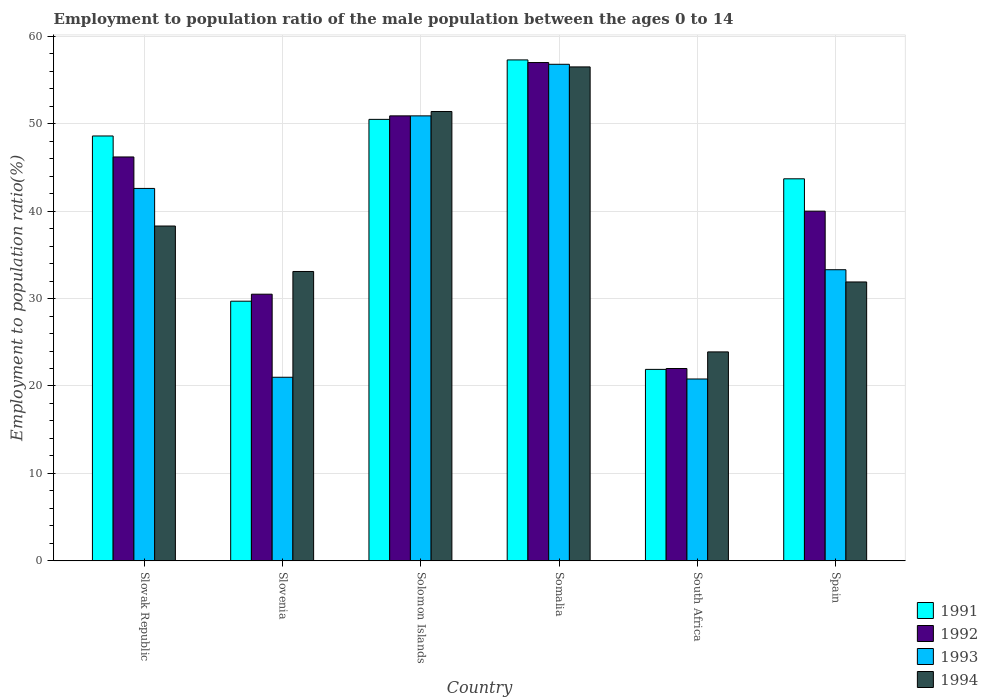How many different coloured bars are there?
Offer a very short reply. 4. Are the number of bars per tick equal to the number of legend labels?
Your response must be concise. Yes. What is the label of the 4th group of bars from the left?
Provide a short and direct response. Somalia. What is the employment to population ratio in 1994 in Somalia?
Offer a very short reply. 56.5. Across all countries, what is the minimum employment to population ratio in 1991?
Your answer should be compact. 21.9. In which country was the employment to population ratio in 1992 maximum?
Your answer should be very brief. Somalia. In which country was the employment to population ratio in 1992 minimum?
Provide a short and direct response. South Africa. What is the total employment to population ratio in 1993 in the graph?
Make the answer very short. 225.4. What is the difference between the employment to population ratio in 1993 in Slovenia and that in South Africa?
Keep it short and to the point. 0.2. What is the difference between the employment to population ratio in 1993 in Somalia and the employment to population ratio in 1992 in Slovenia?
Offer a terse response. 26.3. What is the average employment to population ratio in 1992 per country?
Your answer should be very brief. 41.1. What is the difference between the employment to population ratio of/in 1994 and employment to population ratio of/in 1991 in Solomon Islands?
Ensure brevity in your answer.  0.9. In how many countries, is the employment to population ratio in 1991 greater than 24 %?
Offer a very short reply. 5. What is the ratio of the employment to population ratio in 1991 in Slovak Republic to that in Slovenia?
Offer a very short reply. 1.64. What is the difference between the highest and the second highest employment to population ratio in 1992?
Offer a very short reply. 6.1. What is the difference between the highest and the lowest employment to population ratio in 1991?
Your response must be concise. 35.4. In how many countries, is the employment to population ratio in 1994 greater than the average employment to population ratio in 1994 taken over all countries?
Your response must be concise. 2. Is the sum of the employment to population ratio in 1991 in Somalia and Spain greater than the maximum employment to population ratio in 1992 across all countries?
Offer a terse response. Yes. Is it the case that in every country, the sum of the employment to population ratio in 1992 and employment to population ratio in 1994 is greater than the sum of employment to population ratio in 1993 and employment to population ratio in 1991?
Ensure brevity in your answer.  No. What does the 2nd bar from the left in Somalia represents?
Offer a terse response. 1992. Are all the bars in the graph horizontal?
Provide a succinct answer. No. Does the graph contain any zero values?
Offer a terse response. No. Does the graph contain grids?
Offer a terse response. Yes. How are the legend labels stacked?
Keep it short and to the point. Vertical. What is the title of the graph?
Offer a terse response. Employment to population ratio of the male population between the ages 0 to 14. Does "1963" appear as one of the legend labels in the graph?
Provide a succinct answer. No. What is the label or title of the X-axis?
Offer a very short reply. Country. What is the label or title of the Y-axis?
Give a very brief answer. Employment to population ratio(%). What is the Employment to population ratio(%) in 1991 in Slovak Republic?
Offer a very short reply. 48.6. What is the Employment to population ratio(%) in 1992 in Slovak Republic?
Keep it short and to the point. 46.2. What is the Employment to population ratio(%) in 1993 in Slovak Republic?
Give a very brief answer. 42.6. What is the Employment to population ratio(%) in 1994 in Slovak Republic?
Offer a very short reply. 38.3. What is the Employment to population ratio(%) of 1991 in Slovenia?
Give a very brief answer. 29.7. What is the Employment to population ratio(%) in 1992 in Slovenia?
Give a very brief answer. 30.5. What is the Employment to population ratio(%) in 1993 in Slovenia?
Offer a terse response. 21. What is the Employment to population ratio(%) of 1994 in Slovenia?
Provide a succinct answer. 33.1. What is the Employment to population ratio(%) in 1991 in Solomon Islands?
Provide a short and direct response. 50.5. What is the Employment to population ratio(%) in 1992 in Solomon Islands?
Your answer should be compact. 50.9. What is the Employment to population ratio(%) of 1993 in Solomon Islands?
Provide a short and direct response. 50.9. What is the Employment to population ratio(%) in 1994 in Solomon Islands?
Offer a very short reply. 51.4. What is the Employment to population ratio(%) in 1991 in Somalia?
Your answer should be very brief. 57.3. What is the Employment to population ratio(%) in 1993 in Somalia?
Ensure brevity in your answer.  56.8. What is the Employment to population ratio(%) of 1994 in Somalia?
Provide a succinct answer. 56.5. What is the Employment to population ratio(%) of 1991 in South Africa?
Offer a very short reply. 21.9. What is the Employment to population ratio(%) of 1992 in South Africa?
Provide a succinct answer. 22. What is the Employment to population ratio(%) of 1993 in South Africa?
Ensure brevity in your answer.  20.8. What is the Employment to population ratio(%) in 1994 in South Africa?
Give a very brief answer. 23.9. What is the Employment to population ratio(%) of 1991 in Spain?
Provide a short and direct response. 43.7. What is the Employment to population ratio(%) in 1992 in Spain?
Your response must be concise. 40. What is the Employment to population ratio(%) of 1993 in Spain?
Offer a terse response. 33.3. What is the Employment to population ratio(%) in 1994 in Spain?
Make the answer very short. 31.9. Across all countries, what is the maximum Employment to population ratio(%) in 1991?
Offer a very short reply. 57.3. Across all countries, what is the maximum Employment to population ratio(%) of 1992?
Keep it short and to the point. 57. Across all countries, what is the maximum Employment to population ratio(%) of 1993?
Give a very brief answer. 56.8. Across all countries, what is the maximum Employment to population ratio(%) of 1994?
Give a very brief answer. 56.5. Across all countries, what is the minimum Employment to population ratio(%) of 1991?
Make the answer very short. 21.9. Across all countries, what is the minimum Employment to population ratio(%) of 1993?
Keep it short and to the point. 20.8. Across all countries, what is the minimum Employment to population ratio(%) of 1994?
Provide a short and direct response. 23.9. What is the total Employment to population ratio(%) of 1991 in the graph?
Make the answer very short. 251.7. What is the total Employment to population ratio(%) in 1992 in the graph?
Provide a succinct answer. 246.6. What is the total Employment to population ratio(%) in 1993 in the graph?
Offer a very short reply. 225.4. What is the total Employment to population ratio(%) of 1994 in the graph?
Offer a very short reply. 235.1. What is the difference between the Employment to population ratio(%) of 1992 in Slovak Republic and that in Slovenia?
Give a very brief answer. 15.7. What is the difference between the Employment to population ratio(%) in 1993 in Slovak Republic and that in Slovenia?
Offer a very short reply. 21.6. What is the difference between the Employment to population ratio(%) of 1991 in Slovak Republic and that in Solomon Islands?
Offer a very short reply. -1.9. What is the difference between the Employment to population ratio(%) of 1993 in Slovak Republic and that in Solomon Islands?
Your answer should be compact. -8.3. What is the difference between the Employment to population ratio(%) in 1994 in Slovak Republic and that in Solomon Islands?
Your answer should be very brief. -13.1. What is the difference between the Employment to population ratio(%) of 1993 in Slovak Republic and that in Somalia?
Your answer should be compact. -14.2. What is the difference between the Employment to population ratio(%) of 1994 in Slovak Republic and that in Somalia?
Provide a short and direct response. -18.2. What is the difference between the Employment to population ratio(%) of 1991 in Slovak Republic and that in South Africa?
Offer a very short reply. 26.7. What is the difference between the Employment to population ratio(%) in 1992 in Slovak Republic and that in South Africa?
Your response must be concise. 24.2. What is the difference between the Employment to population ratio(%) in 1993 in Slovak Republic and that in South Africa?
Your response must be concise. 21.8. What is the difference between the Employment to population ratio(%) of 1991 in Slovak Republic and that in Spain?
Provide a short and direct response. 4.9. What is the difference between the Employment to population ratio(%) of 1992 in Slovak Republic and that in Spain?
Give a very brief answer. 6.2. What is the difference between the Employment to population ratio(%) of 1993 in Slovak Republic and that in Spain?
Make the answer very short. 9.3. What is the difference between the Employment to population ratio(%) of 1991 in Slovenia and that in Solomon Islands?
Make the answer very short. -20.8. What is the difference between the Employment to population ratio(%) in 1992 in Slovenia and that in Solomon Islands?
Give a very brief answer. -20.4. What is the difference between the Employment to population ratio(%) of 1993 in Slovenia and that in Solomon Islands?
Keep it short and to the point. -29.9. What is the difference between the Employment to population ratio(%) in 1994 in Slovenia and that in Solomon Islands?
Give a very brief answer. -18.3. What is the difference between the Employment to population ratio(%) of 1991 in Slovenia and that in Somalia?
Your answer should be very brief. -27.6. What is the difference between the Employment to population ratio(%) in 1992 in Slovenia and that in Somalia?
Give a very brief answer. -26.5. What is the difference between the Employment to population ratio(%) of 1993 in Slovenia and that in Somalia?
Your answer should be very brief. -35.8. What is the difference between the Employment to population ratio(%) of 1994 in Slovenia and that in Somalia?
Provide a short and direct response. -23.4. What is the difference between the Employment to population ratio(%) in 1991 in Slovenia and that in South Africa?
Give a very brief answer. 7.8. What is the difference between the Employment to population ratio(%) of 1994 in Slovenia and that in South Africa?
Your answer should be very brief. 9.2. What is the difference between the Employment to population ratio(%) in 1991 in Slovenia and that in Spain?
Ensure brevity in your answer.  -14. What is the difference between the Employment to population ratio(%) in 1991 in Solomon Islands and that in South Africa?
Your answer should be compact. 28.6. What is the difference between the Employment to population ratio(%) of 1992 in Solomon Islands and that in South Africa?
Ensure brevity in your answer.  28.9. What is the difference between the Employment to population ratio(%) in 1993 in Solomon Islands and that in South Africa?
Offer a terse response. 30.1. What is the difference between the Employment to population ratio(%) in 1994 in Solomon Islands and that in South Africa?
Your answer should be compact. 27.5. What is the difference between the Employment to population ratio(%) in 1991 in Solomon Islands and that in Spain?
Offer a terse response. 6.8. What is the difference between the Employment to population ratio(%) of 1992 in Solomon Islands and that in Spain?
Give a very brief answer. 10.9. What is the difference between the Employment to population ratio(%) of 1991 in Somalia and that in South Africa?
Offer a terse response. 35.4. What is the difference between the Employment to population ratio(%) of 1994 in Somalia and that in South Africa?
Give a very brief answer. 32.6. What is the difference between the Employment to population ratio(%) of 1991 in Somalia and that in Spain?
Give a very brief answer. 13.6. What is the difference between the Employment to population ratio(%) in 1993 in Somalia and that in Spain?
Ensure brevity in your answer.  23.5. What is the difference between the Employment to population ratio(%) in 1994 in Somalia and that in Spain?
Provide a succinct answer. 24.6. What is the difference between the Employment to population ratio(%) in 1991 in South Africa and that in Spain?
Offer a very short reply. -21.8. What is the difference between the Employment to population ratio(%) in 1992 in South Africa and that in Spain?
Give a very brief answer. -18. What is the difference between the Employment to population ratio(%) of 1991 in Slovak Republic and the Employment to population ratio(%) of 1993 in Slovenia?
Provide a short and direct response. 27.6. What is the difference between the Employment to population ratio(%) in 1992 in Slovak Republic and the Employment to population ratio(%) in 1993 in Slovenia?
Make the answer very short. 25.2. What is the difference between the Employment to population ratio(%) of 1992 in Slovak Republic and the Employment to population ratio(%) of 1994 in Slovenia?
Provide a succinct answer. 13.1. What is the difference between the Employment to population ratio(%) of 1991 in Slovak Republic and the Employment to population ratio(%) of 1992 in Solomon Islands?
Make the answer very short. -2.3. What is the difference between the Employment to population ratio(%) of 1991 in Slovak Republic and the Employment to population ratio(%) of 1994 in Solomon Islands?
Your answer should be compact. -2.8. What is the difference between the Employment to population ratio(%) in 1992 in Slovak Republic and the Employment to population ratio(%) in 1994 in Solomon Islands?
Your answer should be very brief. -5.2. What is the difference between the Employment to population ratio(%) of 1993 in Slovak Republic and the Employment to population ratio(%) of 1994 in Solomon Islands?
Your answer should be very brief. -8.8. What is the difference between the Employment to population ratio(%) in 1992 in Slovak Republic and the Employment to population ratio(%) in 1993 in Somalia?
Make the answer very short. -10.6. What is the difference between the Employment to population ratio(%) of 1992 in Slovak Republic and the Employment to population ratio(%) of 1994 in Somalia?
Provide a short and direct response. -10.3. What is the difference between the Employment to population ratio(%) in 1991 in Slovak Republic and the Employment to population ratio(%) in 1992 in South Africa?
Keep it short and to the point. 26.6. What is the difference between the Employment to population ratio(%) of 1991 in Slovak Republic and the Employment to population ratio(%) of 1993 in South Africa?
Your answer should be compact. 27.8. What is the difference between the Employment to population ratio(%) of 1991 in Slovak Republic and the Employment to population ratio(%) of 1994 in South Africa?
Your answer should be very brief. 24.7. What is the difference between the Employment to population ratio(%) of 1992 in Slovak Republic and the Employment to population ratio(%) of 1993 in South Africa?
Make the answer very short. 25.4. What is the difference between the Employment to population ratio(%) in 1992 in Slovak Republic and the Employment to population ratio(%) in 1994 in South Africa?
Provide a succinct answer. 22.3. What is the difference between the Employment to population ratio(%) in 1991 in Slovak Republic and the Employment to population ratio(%) in 1992 in Spain?
Provide a succinct answer. 8.6. What is the difference between the Employment to population ratio(%) in 1991 in Slovak Republic and the Employment to population ratio(%) in 1993 in Spain?
Provide a short and direct response. 15.3. What is the difference between the Employment to population ratio(%) in 1991 in Slovak Republic and the Employment to population ratio(%) in 1994 in Spain?
Provide a succinct answer. 16.7. What is the difference between the Employment to population ratio(%) in 1992 in Slovak Republic and the Employment to population ratio(%) in 1993 in Spain?
Your answer should be very brief. 12.9. What is the difference between the Employment to population ratio(%) of 1993 in Slovak Republic and the Employment to population ratio(%) of 1994 in Spain?
Provide a short and direct response. 10.7. What is the difference between the Employment to population ratio(%) in 1991 in Slovenia and the Employment to population ratio(%) in 1992 in Solomon Islands?
Keep it short and to the point. -21.2. What is the difference between the Employment to population ratio(%) of 1991 in Slovenia and the Employment to population ratio(%) of 1993 in Solomon Islands?
Your response must be concise. -21.2. What is the difference between the Employment to population ratio(%) in 1991 in Slovenia and the Employment to population ratio(%) in 1994 in Solomon Islands?
Offer a terse response. -21.7. What is the difference between the Employment to population ratio(%) of 1992 in Slovenia and the Employment to population ratio(%) of 1993 in Solomon Islands?
Offer a very short reply. -20.4. What is the difference between the Employment to population ratio(%) of 1992 in Slovenia and the Employment to population ratio(%) of 1994 in Solomon Islands?
Offer a terse response. -20.9. What is the difference between the Employment to population ratio(%) in 1993 in Slovenia and the Employment to population ratio(%) in 1994 in Solomon Islands?
Give a very brief answer. -30.4. What is the difference between the Employment to population ratio(%) of 1991 in Slovenia and the Employment to population ratio(%) of 1992 in Somalia?
Offer a very short reply. -27.3. What is the difference between the Employment to population ratio(%) of 1991 in Slovenia and the Employment to population ratio(%) of 1993 in Somalia?
Provide a short and direct response. -27.1. What is the difference between the Employment to population ratio(%) of 1991 in Slovenia and the Employment to population ratio(%) of 1994 in Somalia?
Offer a very short reply. -26.8. What is the difference between the Employment to population ratio(%) of 1992 in Slovenia and the Employment to population ratio(%) of 1993 in Somalia?
Make the answer very short. -26.3. What is the difference between the Employment to population ratio(%) in 1992 in Slovenia and the Employment to population ratio(%) in 1994 in Somalia?
Provide a succinct answer. -26. What is the difference between the Employment to population ratio(%) in 1993 in Slovenia and the Employment to population ratio(%) in 1994 in Somalia?
Give a very brief answer. -35.5. What is the difference between the Employment to population ratio(%) of 1991 in Slovenia and the Employment to population ratio(%) of 1992 in South Africa?
Offer a very short reply. 7.7. What is the difference between the Employment to population ratio(%) of 1992 in Slovenia and the Employment to population ratio(%) of 1993 in South Africa?
Keep it short and to the point. 9.7. What is the difference between the Employment to population ratio(%) in 1991 in Slovenia and the Employment to population ratio(%) in 1993 in Spain?
Ensure brevity in your answer.  -3.6. What is the difference between the Employment to population ratio(%) of 1992 in Slovenia and the Employment to population ratio(%) of 1994 in Spain?
Give a very brief answer. -1.4. What is the difference between the Employment to population ratio(%) in 1991 in Solomon Islands and the Employment to population ratio(%) in 1993 in Somalia?
Your response must be concise. -6.3. What is the difference between the Employment to population ratio(%) in 1991 in Solomon Islands and the Employment to population ratio(%) in 1994 in Somalia?
Provide a succinct answer. -6. What is the difference between the Employment to population ratio(%) of 1992 in Solomon Islands and the Employment to population ratio(%) of 1994 in Somalia?
Your answer should be compact. -5.6. What is the difference between the Employment to population ratio(%) in 1993 in Solomon Islands and the Employment to population ratio(%) in 1994 in Somalia?
Give a very brief answer. -5.6. What is the difference between the Employment to population ratio(%) in 1991 in Solomon Islands and the Employment to population ratio(%) in 1993 in South Africa?
Provide a short and direct response. 29.7. What is the difference between the Employment to population ratio(%) of 1991 in Solomon Islands and the Employment to population ratio(%) of 1994 in South Africa?
Offer a terse response. 26.6. What is the difference between the Employment to population ratio(%) in 1992 in Solomon Islands and the Employment to population ratio(%) in 1993 in South Africa?
Offer a very short reply. 30.1. What is the difference between the Employment to population ratio(%) in 1992 in Solomon Islands and the Employment to population ratio(%) in 1994 in South Africa?
Your answer should be compact. 27. What is the difference between the Employment to population ratio(%) in 1991 in Solomon Islands and the Employment to population ratio(%) in 1992 in Spain?
Give a very brief answer. 10.5. What is the difference between the Employment to population ratio(%) in 1991 in Solomon Islands and the Employment to population ratio(%) in 1994 in Spain?
Provide a succinct answer. 18.6. What is the difference between the Employment to population ratio(%) in 1991 in Somalia and the Employment to population ratio(%) in 1992 in South Africa?
Make the answer very short. 35.3. What is the difference between the Employment to population ratio(%) of 1991 in Somalia and the Employment to population ratio(%) of 1993 in South Africa?
Keep it short and to the point. 36.5. What is the difference between the Employment to population ratio(%) of 1991 in Somalia and the Employment to population ratio(%) of 1994 in South Africa?
Offer a very short reply. 33.4. What is the difference between the Employment to population ratio(%) in 1992 in Somalia and the Employment to population ratio(%) in 1993 in South Africa?
Keep it short and to the point. 36.2. What is the difference between the Employment to population ratio(%) of 1992 in Somalia and the Employment to population ratio(%) of 1994 in South Africa?
Provide a short and direct response. 33.1. What is the difference between the Employment to population ratio(%) of 1993 in Somalia and the Employment to population ratio(%) of 1994 in South Africa?
Your answer should be very brief. 32.9. What is the difference between the Employment to population ratio(%) of 1991 in Somalia and the Employment to population ratio(%) of 1993 in Spain?
Offer a terse response. 24. What is the difference between the Employment to population ratio(%) in 1991 in Somalia and the Employment to population ratio(%) in 1994 in Spain?
Offer a terse response. 25.4. What is the difference between the Employment to population ratio(%) of 1992 in Somalia and the Employment to population ratio(%) of 1993 in Spain?
Give a very brief answer. 23.7. What is the difference between the Employment to population ratio(%) in 1992 in Somalia and the Employment to population ratio(%) in 1994 in Spain?
Offer a terse response. 25.1. What is the difference between the Employment to population ratio(%) in 1993 in Somalia and the Employment to population ratio(%) in 1994 in Spain?
Your response must be concise. 24.9. What is the difference between the Employment to population ratio(%) of 1991 in South Africa and the Employment to population ratio(%) of 1992 in Spain?
Offer a terse response. -18.1. What is the difference between the Employment to population ratio(%) of 1991 in South Africa and the Employment to population ratio(%) of 1993 in Spain?
Your answer should be very brief. -11.4. What is the difference between the Employment to population ratio(%) in 1992 in South Africa and the Employment to population ratio(%) in 1993 in Spain?
Your response must be concise. -11.3. What is the difference between the Employment to population ratio(%) in 1992 in South Africa and the Employment to population ratio(%) in 1994 in Spain?
Ensure brevity in your answer.  -9.9. What is the average Employment to population ratio(%) of 1991 per country?
Provide a succinct answer. 41.95. What is the average Employment to population ratio(%) of 1992 per country?
Your answer should be compact. 41.1. What is the average Employment to population ratio(%) of 1993 per country?
Your answer should be very brief. 37.57. What is the average Employment to population ratio(%) in 1994 per country?
Give a very brief answer. 39.18. What is the difference between the Employment to population ratio(%) of 1991 and Employment to population ratio(%) of 1993 in Slovak Republic?
Your response must be concise. 6. What is the difference between the Employment to population ratio(%) of 1993 and Employment to population ratio(%) of 1994 in Slovak Republic?
Provide a short and direct response. 4.3. What is the difference between the Employment to population ratio(%) of 1991 and Employment to population ratio(%) of 1992 in Slovenia?
Provide a short and direct response. -0.8. What is the difference between the Employment to population ratio(%) of 1991 and Employment to population ratio(%) of 1994 in Slovenia?
Your answer should be very brief. -3.4. What is the difference between the Employment to population ratio(%) of 1992 and Employment to population ratio(%) of 1994 in Slovenia?
Ensure brevity in your answer.  -2.6. What is the difference between the Employment to population ratio(%) of 1991 and Employment to population ratio(%) of 1993 in Solomon Islands?
Your answer should be very brief. -0.4. What is the difference between the Employment to population ratio(%) of 1993 and Employment to population ratio(%) of 1994 in Solomon Islands?
Your response must be concise. -0.5. What is the difference between the Employment to population ratio(%) of 1991 and Employment to population ratio(%) of 1992 in Somalia?
Ensure brevity in your answer.  0.3. What is the difference between the Employment to population ratio(%) of 1991 and Employment to population ratio(%) of 1994 in Somalia?
Provide a short and direct response. 0.8. What is the difference between the Employment to population ratio(%) of 1992 and Employment to population ratio(%) of 1993 in Somalia?
Make the answer very short. 0.2. What is the difference between the Employment to population ratio(%) of 1992 and Employment to population ratio(%) of 1994 in Somalia?
Your answer should be compact. 0.5. What is the difference between the Employment to population ratio(%) in 1991 and Employment to population ratio(%) in 1992 in South Africa?
Your answer should be very brief. -0.1. What is the difference between the Employment to population ratio(%) in 1991 and Employment to population ratio(%) in 1994 in South Africa?
Provide a succinct answer. -2. What is the difference between the Employment to population ratio(%) of 1992 and Employment to population ratio(%) of 1993 in South Africa?
Give a very brief answer. 1.2. What is the difference between the Employment to population ratio(%) in 1991 and Employment to population ratio(%) in 1992 in Spain?
Provide a short and direct response. 3.7. What is the difference between the Employment to population ratio(%) in 1991 and Employment to population ratio(%) in 1994 in Spain?
Offer a terse response. 11.8. What is the difference between the Employment to population ratio(%) in 1992 and Employment to population ratio(%) in 1994 in Spain?
Your response must be concise. 8.1. What is the ratio of the Employment to population ratio(%) of 1991 in Slovak Republic to that in Slovenia?
Give a very brief answer. 1.64. What is the ratio of the Employment to population ratio(%) of 1992 in Slovak Republic to that in Slovenia?
Provide a succinct answer. 1.51. What is the ratio of the Employment to population ratio(%) of 1993 in Slovak Republic to that in Slovenia?
Provide a short and direct response. 2.03. What is the ratio of the Employment to population ratio(%) of 1994 in Slovak Republic to that in Slovenia?
Keep it short and to the point. 1.16. What is the ratio of the Employment to population ratio(%) in 1991 in Slovak Republic to that in Solomon Islands?
Ensure brevity in your answer.  0.96. What is the ratio of the Employment to population ratio(%) of 1992 in Slovak Republic to that in Solomon Islands?
Make the answer very short. 0.91. What is the ratio of the Employment to population ratio(%) in 1993 in Slovak Republic to that in Solomon Islands?
Offer a very short reply. 0.84. What is the ratio of the Employment to population ratio(%) of 1994 in Slovak Republic to that in Solomon Islands?
Offer a terse response. 0.75. What is the ratio of the Employment to population ratio(%) of 1991 in Slovak Republic to that in Somalia?
Provide a succinct answer. 0.85. What is the ratio of the Employment to population ratio(%) of 1992 in Slovak Republic to that in Somalia?
Your answer should be compact. 0.81. What is the ratio of the Employment to population ratio(%) of 1994 in Slovak Republic to that in Somalia?
Make the answer very short. 0.68. What is the ratio of the Employment to population ratio(%) in 1991 in Slovak Republic to that in South Africa?
Provide a succinct answer. 2.22. What is the ratio of the Employment to population ratio(%) in 1993 in Slovak Republic to that in South Africa?
Your answer should be compact. 2.05. What is the ratio of the Employment to population ratio(%) of 1994 in Slovak Republic to that in South Africa?
Provide a short and direct response. 1.6. What is the ratio of the Employment to population ratio(%) of 1991 in Slovak Republic to that in Spain?
Ensure brevity in your answer.  1.11. What is the ratio of the Employment to population ratio(%) of 1992 in Slovak Republic to that in Spain?
Provide a short and direct response. 1.16. What is the ratio of the Employment to population ratio(%) in 1993 in Slovak Republic to that in Spain?
Your answer should be compact. 1.28. What is the ratio of the Employment to population ratio(%) of 1994 in Slovak Republic to that in Spain?
Your answer should be very brief. 1.2. What is the ratio of the Employment to population ratio(%) in 1991 in Slovenia to that in Solomon Islands?
Keep it short and to the point. 0.59. What is the ratio of the Employment to population ratio(%) of 1992 in Slovenia to that in Solomon Islands?
Provide a short and direct response. 0.6. What is the ratio of the Employment to population ratio(%) in 1993 in Slovenia to that in Solomon Islands?
Offer a terse response. 0.41. What is the ratio of the Employment to population ratio(%) in 1994 in Slovenia to that in Solomon Islands?
Offer a very short reply. 0.64. What is the ratio of the Employment to population ratio(%) of 1991 in Slovenia to that in Somalia?
Offer a very short reply. 0.52. What is the ratio of the Employment to population ratio(%) of 1992 in Slovenia to that in Somalia?
Your answer should be very brief. 0.54. What is the ratio of the Employment to population ratio(%) in 1993 in Slovenia to that in Somalia?
Offer a very short reply. 0.37. What is the ratio of the Employment to population ratio(%) of 1994 in Slovenia to that in Somalia?
Offer a very short reply. 0.59. What is the ratio of the Employment to population ratio(%) of 1991 in Slovenia to that in South Africa?
Make the answer very short. 1.36. What is the ratio of the Employment to population ratio(%) of 1992 in Slovenia to that in South Africa?
Offer a terse response. 1.39. What is the ratio of the Employment to population ratio(%) of 1993 in Slovenia to that in South Africa?
Give a very brief answer. 1.01. What is the ratio of the Employment to population ratio(%) in 1994 in Slovenia to that in South Africa?
Ensure brevity in your answer.  1.38. What is the ratio of the Employment to population ratio(%) in 1991 in Slovenia to that in Spain?
Keep it short and to the point. 0.68. What is the ratio of the Employment to population ratio(%) of 1992 in Slovenia to that in Spain?
Your answer should be very brief. 0.76. What is the ratio of the Employment to population ratio(%) in 1993 in Slovenia to that in Spain?
Provide a short and direct response. 0.63. What is the ratio of the Employment to population ratio(%) in 1994 in Slovenia to that in Spain?
Your response must be concise. 1.04. What is the ratio of the Employment to population ratio(%) in 1991 in Solomon Islands to that in Somalia?
Your response must be concise. 0.88. What is the ratio of the Employment to population ratio(%) of 1992 in Solomon Islands to that in Somalia?
Provide a short and direct response. 0.89. What is the ratio of the Employment to population ratio(%) in 1993 in Solomon Islands to that in Somalia?
Provide a succinct answer. 0.9. What is the ratio of the Employment to population ratio(%) of 1994 in Solomon Islands to that in Somalia?
Keep it short and to the point. 0.91. What is the ratio of the Employment to population ratio(%) in 1991 in Solomon Islands to that in South Africa?
Offer a very short reply. 2.31. What is the ratio of the Employment to population ratio(%) in 1992 in Solomon Islands to that in South Africa?
Keep it short and to the point. 2.31. What is the ratio of the Employment to population ratio(%) in 1993 in Solomon Islands to that in South Africa?
Provide a succinct answer. 2.45. What is the ratio of the Employment to population ratio(%) of 1994 in Solomon Islands to that in South Africa?
Provide a succinct answer. 2.15. What is the ratio of the Employment to population ratio(%) in 1991 in Solomon Islands to that in Spain?
Your response must be concise. 1.16. What is the ratio of the Employment to population ratio(%) in 1992 in Solomon Islands to that in Spain?
Keep it short and to the point. 1.27. What is the ratio of the Employment to population ratio(%) of 1993 in Solomon Islands to that in Spain?
Your response must be concise. 1.53. What is the ratio of the Employment to population ratio(%) of 1994 in Solomon Islands to that in Spain?
Provide a short and direct response. 1.61. What is the ratio of the Employment to population ratio(%) in 1991 in Somalia to that in South Africa?
Your answer should be very brief. 2.62. What is the ratio of the Employment to population ratio(%) in 1992 in Somalia to that in South Africa?
Make the answer very short. 2.59. What is the ratio of the Employment to population ratio(%) in 1993 in Somalia to that in South Africa?
Provide a short and direct response. 2.73. What is the ratio of the Employment to population ratio(%) in 1994 in Somalia to that in South Africa?
Ensure brevity in your answer.  2.36. What is the ratio of the Employment to population ratio(%) in 1991 in Somalia to that in Spain?
Offer a very short reply. 1.31. What is the ratio of the Employment to population ratio(%) of 1992 in Somalia to that in Spain?
Your answer should be compact. 1.43. What is the ratio of the Employment to population ratio(%) in 1993 in Somalia to that in Spain?
Offer a very short reply. 1.71. What is the ratio of the Employment to population ratio(%) in 1994 in Somalia to that in Spain?
Your answer should be compact. 1.77. What is the ratio of the Employment to population ratio(%) of 1991 in South Africa to that in Spain?
Provide a succinct answer. 0.5. What is the ratio of the Employment to population ratio(%) in 1992 in South Africa to that in Spain?
Provide a short and direct response. 0.55. What is the ratio of the Employment to population ratio(%) of 1993 in South Africa to that in Spain?
Provide a succinct answer. 0.62. What is the ratio of the Employment to population ratio(%) in 1994 in South Africa to that in Spain?
Your answer should be compact. 0.75. What is the difference between the highest and the second highest Employment to population ratio(%) in 1994?
Ensure brevity in your answer.  5.1. What is the difference between the highest and the lowest Employment to population ratio(%) in 1991?
Provide a short and direct response. 35.4. What is the difference between the highest and the lowest Employment to population ratio(%) in 1992?
Make the answer very short. 35. What is the difference between the highest and the lowest Employment to population ratio(%) of 1994?
Provide a short and direct response. 32.6. 